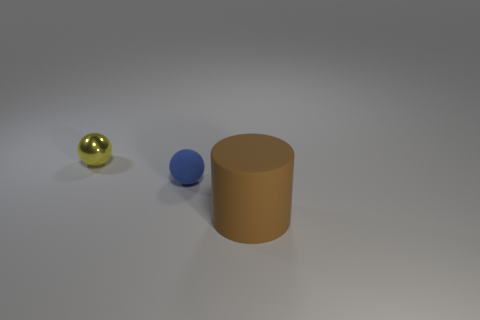What color is the tiny sphere on the left side of the small matte ball in front of the yellow sphere?
Your response must be concise. Yellow. How big is the rubber object left of the object that is in front of the small object right of the small yellow metallic ball?
Offer a terse response. Small. Are the yellow ball and the thing that is to the right of the tiny blue matte object made of the same material?
Keep it short and to the point. No. There is a ball that is made of the same material as the cylinder; what is its size?
Offer a terse response. Small. Are there any other blue things that have the same shape as the large rubber object?
Your response must be concise. No. What number of objects are either things that are to the right of the yellow shiny sphere or small blue things?
Your answer should be compact. 2. Do the tiny object in front of the yellow metal ball and the rubber object right of the tiny matte sphere have the same color?
Offer a very short reply. No. The brown matte thing is what size?
Give a very brief answer. Large. What number of tiny objects are either blue matte balls or matte things?
Offer a very short reply. 1. What is the color of the rubber thing that is the same size as the metal sphere?
Give a very brief answer. Blue. 